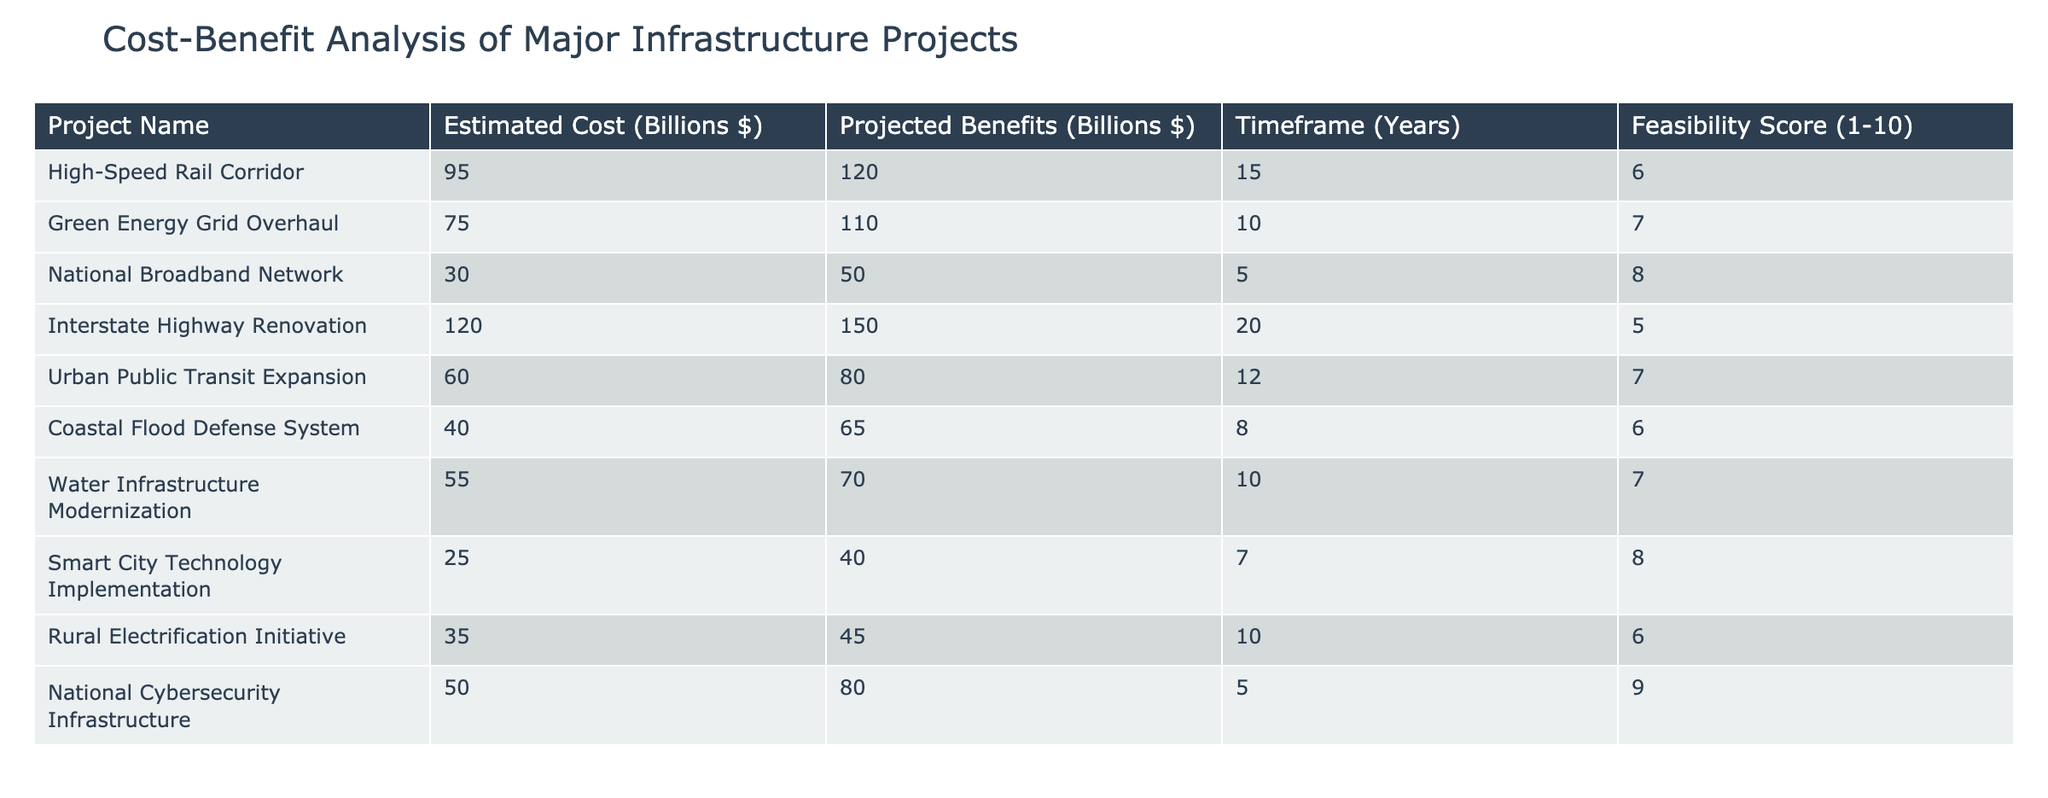What is the estimated cost of the Green Energy Grid Overhaul project? The table lists the estimated costs of various projects. For the Green Energy Grid Overhaul, the estimated cost is explicitly shown in the relevant row of the table.
Answer: 75 billion dollars Which project has the highest feasibility score? To find the highest feasibility score, the scores listed in the feasibility column need to be compared. By examining the scores, it is clear that the National Cybersecurity Infrastructure has the highest score of 9.
Answer: National Cybersecurity Infrastructure What is the projected benefit of the Urban Public Transit Expansion project? According to the table, the projected benefits of each project can be found in the benefits column. The Urban Public Transit Expansion shows projected benefits of 80 billion dollars.
Answer: 80 billion dollars What is the total estimated cost of all projects listed in the table? The total estimated cost can be calculated by summing up the estimated costs from the estimated cost column across all projects. The sum is 95 + 75 + 30 + 120 + 60 + 40 + 55 + 25 + 35 + 50 = 585 billion dollars.
Answer: 585 billion dollars Is the projected benefit of the National Broadband Network greater than its estimated cost? Comparing the estimated cost (30 billion dollars) with the projected benefit (50 billion dollars) shows that the benefit is indeed greater, since 50 is more than 30.
Answer: Yes What is the average feasibility score of all projects? To find the average feasibility score, add all scores together (6 + 7 + 8 + 5 + 7 + 6 + 7 + 8 + 6 + 9 = 69) and then divide by the number of projects (10). Therefore, the average is 69/10 = 6.9.
Answer: 6.9 Which project has the lowest projected benefits relative to its estimated cost? Calculating the benefits-to-cost ratio for each project allows for comparison. The ratio for each project can be obtained by dividing the projected benefits by the estimated costs. Upon calculation, the Smart City Technology Implementation has the lowest ratio, as it provides a benefit of 40 billion dollars for a cost of 25 billion dollars (1.6), which is relatively low compared to others.
Answer: Smart City Technology Implementation What is the difference between the projected benefits of the Interstate Highway Renovation and the Coastal Flood Defense System? The projected benefit of the Interstate Highway Renovation is 150 billion dollars, while for the Coastal Flood Defense System it is 65 billion dollars. The difference can be calculated by subtracting the latter from the former (150 - 65 = 85).
Answer: 85 billion dollars Which project has a timeframe of 10 years? The timeframe column indicates the duration for each project, and by scanning through the entries, we can see that both the Green Energy Grid Overhaul and Water Infrastructure Modernization have a timeframe of 10 years.
Answer: Green Energy Grid Overhaul, Water Infrastructure Modernization 